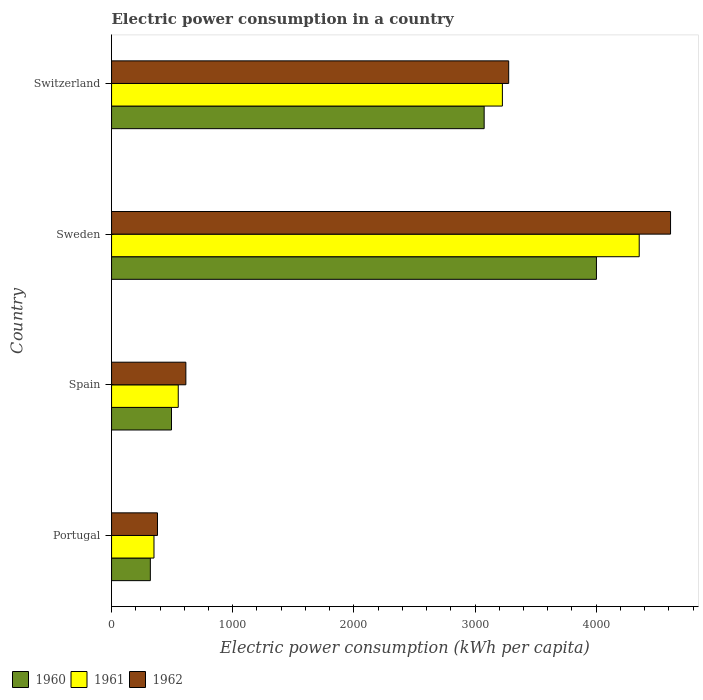How many groups of bars are there?
Provide a short and direct response. 4. How many bars are there on the 4th tick from the top?
Give a very brief answer. 3. How many bars are there on the 3rd tick from the bottom?
Provide a succinct answer. 3. In how many cases, is the number of bars for a given country not equal to the number of legend labels?
Your answer should be very brief. 0. What is the electric power consumption in in 1961 in Spain?
Your response must be concise. 550.44. Across all countries, what is the maximum electric power consumption in in 1961?
Offer a very short reply. 4355.45. Across all countries, what is the minimum electric power consumption in in 1962?
Your answer should be very brief. 379.14. In which country was the electric power consumption in in 1962 minimum?
Provide a succinct answer. Portugal. What is the total electric power consumption in in 1961 in the graph?
Offer a terse response. 8482.08. What is the difference between the electric power consumption in in 1960 in Portugal and that in Sweden?
Make the answer very short. -3682.15. What is the difference between the electric power consumption in in 1960 in Portugal and the electric power consumption in in 1962 in Sweden?
Give a very brief answer. -4293.81. What is the average electric power consumption in in 1961 per country?
Offer a very short reply. 2120.52. What is the difference between the electric power consumption in in 1961 and electric power consumption in in 1960 in Portugal?
Your response must be concise. 30.02. What is the ratio of the electric power consumption in in 1960 in Spain to that in Sweden?
Make the answer very short. 0.12. Is the difference between the electric power consumption in in 1961 in Spain and Switzerland greater than the difference between the electric power consumption in in 1960 in Spain and Switzerland?
Ensure brevity in your answer.  No. What is the difference between the highest and the second highest electric power consumption in in 1960?
Offer a terse response. 926.77. What is the difference between the highest and the lowest electric power consumption in in 1961?
Your answer should be compact. 4005.26. In how many countries, is the electric power consumption in in 1960 greater than the average electric power consumption in in 1960 taken over all countries?
Provide a succinct answer. 2. How many bars are there?
Offer a terse response. 12. Are all the bars in the graph horizontal?
Ensure brevity in your answer.  Yes. What is the difference between two consecutive major ticks on the X-axis?
Give a very brief answer. 1000. Are the values on the major ticks of X-axis written in scientific E-notation?
Your answer should be compact. No. Does the graph contain any zero values?
Give a very brief answer. No. Where does the legend appear in the graph?
Ensure brevity in your answer.  Bottom left. How many legend labels are there?
Your response must be concise. 3. What is the title of the graph?
Your answer should be compact. Electric power consumption in a country. What is the label or title of the X-axis?
Ensure brevity in your answer.  Electric power consumption (kWh per capita). What is the Electric power consumption (kWh per capita) of 1960 in Portugal?
Your answer should be very brief. 320.17. What is the Electric power consumption (kWh per capita) in 1961 in Portugal?
Ensure brevity in your answer.  350.19. What is the Electric power consumption (kWh per capita) in 1962 in Portugal?
Offer a terse response. 379.14. What is the Electric power consumption (kWh per capita) of 1960 in Spain?
Offer a very short reply. 494.8. What is the Electric power consumption (kWh per capita) of 1961 in Spain?
Provide a short and direct response. 550.44. What is the Electric power consumption (kWh per capita) of 1962 in Spain?
Offer a very short reply. 613.25. What is the Electric power consumption (kWh per capita) of 1960 in Sweden?
Give a very brief answer. 4002.32. What is the Electric power consumption (kWh per capita) of 1961 in Sweden?
Provide a short and direct response. 4355.45. What is the Electric power consumption (kWh per capita) of 1962 in Sweden?
Your response must be concise. 4613.98. What is the Electric power consumption (kWh per capita) of 1960 in Switzerland?
Your answer should be compact. 3075.55. What is the Electric power consumption (kWh per capita) of 1961 in Switzerland?
Offer a very short reply. 3225.99. What is the Electric power consumption (kWh per capita) of 1962 in Switzerland?
Give a very brief answer. 3278.01. Across all countries, what is the maximum Electric power consumption (kWh per capita) in 1960?
Provide a succinct answer. 4002.32. Across all countries, what is the maximum Electric power consumption (kWh per capita) of 1961?
Your response must be concise. 4355.45. Across all countries, what is the maximum Electric power consumption (kWh per capita) in 1962?
Give a very brief answer. 4613.98. Across all countries, what is the minimum Electric power consumption (kWh per capita) in 1960?
Provide a succinct answer. 320.17. Across all countries, what is the minimum Electric power consumption (kWh per capita) of 1961?
Give a very brief answer. 350.19. Across all countries, what is the minimum Electric power consumption (kWh per capita) of 1962?
Your answer should be very brief. 379.14. What is the total Electric power consumption (kWh per capita) of 1960 in the graph?
Your answer should be compact. 7892.84. What is the total Electric power consumption (kWh per capita) of 1961 in the graph?
Give a very brief answer. 8482.08. What is the total Electric power consumption (kWh per capita) of 1962 in the graph?
Your response must be concise. 8884.37. What is the difference between the Electric power consumption (kWh per capita) in 1960 in Portugal and that in Spain?
Your answer should be compact. -174.62. What is the difference between the Electric power consumption (kWh per capita) in 1961 in Portugal and that in Spain?
Your answer should be very brief. -200.24. What is the difference between the Electric power consumption (kWh per capita) in 1962 in Portugal and that in Spain?
Make the answer very short. -234.11. What is the difference between the Electric power consumption (kWh per capita) in 1960 in Portugal and that in Sweden?
Your answer should be compact. -3682.15. What is the difference between the Electric power consumption (kWh per capita) in 1961 in Portugal and that in Sweden?
Offer a terse response. -4005.26. What is the difference between the Electric power consumption (kWh per capita) in 1962 in Portugal and that in Sweden?
Your response must be concise. -4234.84. What is the difference between the Electric power consumption (kWh per capita) of 1960 in Portugal and that in Switzerland?
Make the answer very short. -2755.38. What is the difference between the Electric power consumption (kWh per capita) in 1961 in Portugal and that in Switzerland?
Offer a very short reply. -2875.8. What is the difference between the Electric power consumption (kWh per capita) in 1962 in Portugal and that in Switzerland?
Provide a succinct answer. -2898.86. What is the difference between the Electric power consumption (kWh per capita) in 1960 in Spain and that in Sweden?
Make the answer very short. -3507.53. What is the difference between the Electric power consumption (kWh per capita) in 1961 in Spain and that in Sweden?
Your answer should be very brief. -3805.02. What is the difference between the Electric power consumption (kWh per capita) in 1962 in Spain and that in Sweden?
Your response must be concise. -4000.73. What is the difference between the Electric power consumption (kWh per capita) of 1960 in Spain and that in Switzerland?
Make the answer very short. -2580.75. What is the difference between the Electric power consumption (kWh per capita) in 1961 in Spain and that in Switzerland?
Your answer should be compact. -2675.56. What is the difference between the Electric power consumption (kWh per capita) of 1962 in Spain and that in Switzerland?
Ensure brevity in your answer.  -2664.76. What is the difference between the Electric power consumption (kWh per capita) of 1960 in Sweden and that in Switzerland?
Give a very brief answer. 926.77. What is the difference between the Electric power consumption (kWh per capita) in 1961 in Sweden and that in Switzerland?
Your answer should be very brief. 1129.46. What is the difference between the Electric power consumption (kWh per capita) of 1962 in Sweden and that in Switzerland?
Your answer should be very brief. 1335.97. What is the difference between the Electric power consumption (kWh per capita) of 1960 in Portugal and the Electric power consumption (kWh per capita) of 1961 in Spain?
Offer a very short reply. -230.26. What is the difference between the Electric power consumption (kWh per capita) in 1960 in Portugal and the Electric power consumption (kWh per capita) in 1962 in Spain?
Your response must be concise. -293.07. What is the difference between the Electric power consumption (kWh per capita) in 1961 in Portugal and the Electric power consumption (kWh per capita) in 1962 in Spain?
Your answer should be compact. -263.05. What is the difference between the Electric power consumption (kWh per capita) of 1960 in Portugal and the Electric power consumption (kWh per capita) of 1961 in Sweden?
Give a very brief answer. -4035.28. What is the difference between the Electric power consumption (kWh per capita) in 1960 in Portugal and the Electric power consumption (kWh per capita) in 1962 in Sweden?
Keep it short and to the point. -4293.81. What is the difference between the Electric power consumption (kWh per capita) of 1961 in Portugal and the Electric power consumption (kWh per capita) of 1962 in Sweden?
Your answer should be compact. -4263.78. What is the difference between the Electric power consumption (kWh per capita) of 1960 in Portugal and the Electric power consumption (kWh per capita) of 1961 in Switzerland?
Provide a succinct answer. -2905.82. What is the difference between the Electric power consumption (kWh per capita) in 1960 in Portugal and the Electric power consumption (kWh per capita) in 1962 in Switzerland?
Ensure brevity in your answer.  -2957.83. What is the difference between the Electric power consumption (kWh per capita) in 1961 in Portugal and the Electric power consumption (kWh per capita) in 1962 in Switzerland?
Give a very brief answer. -2927.81. What is the difference between the Electric power consumption (kWh per capita) in 1960 in Spain and the Electric power consumption (kWh per capita) in 1961 in Sweden?
Provide a succinct answer. -3860.66. What is the difference between the Electric power consumption (kWh per capita) of 1960 in Spain and the Electric power consumption (kWh per capita) of 1962 in Sweden?
Give a very brief answer. -4119.18. What is the difference between the Electric power consumption (kWh per capita) in 1961 in Spain and the Electric power consumption (kWh per capita) in 1962 in Sweden?
Keep it short and to the point. -4063.54. What is the difference between the Electric power consumption (kWh per capita) in 1960 in Spain and the Electric power consumption (kWh per capita) in 1961 in Switzerland?
Provide a short and direct response. -2731.2. What is the difference between the Electric power consumption (kWh per capita) in 1960 in Spain and the Electric power consumption (kWh per capita) in 1962 in Switzerland?
Your answer should be compact. -2783.21. What is the difference between the Electric power consumption (kWh per capita) of 1961 in Spain and the Electric power consumption (kWh per capita) of 1962 in Switzerland?
Offer a terse response. -2727.57. What is the difference between the Electric power consumption (kWh per capita) of 1960 in Sweden and the Electric power consumption (kWh per capita) of 1961 in Switzerland?
Your answer should be very brief. 776.33. What is the difference between the Electric power consumption (kWh per capita) in 1960 in Sweden and the Electric power consumption (kWh per capita) in 1962 in Switzerland?
Offer a very short reply. 724.32. What is the difference between the Electric power consumption (kWh per capita) of 1961 in Sweden and the Electric power consumption (kWh per capita) of 1962 in Switzerland?
Offer a very short reply. 1077.45. What is the average Electric power consumption (kWh per capita) in 1960 per country?
Make the answer very short. 1973.21. What is the average Electric power consumption (kWh per capita) in 1961 per country?
Make the answer very short. 2120.52. What is the average Electric power consumption (kWh per capita) of 1962 per country?
Your answer should be very brief. 2221.09. What is the difference between the Electric power consumption (kWh per capita) in 1960 and Electric power consumption (kWh per capita) in 1961 in Portugal?
Your response must be concise. -30.02. What is the difference between the Electric power consumption (kWh per capita) of 1960 and Electric power consumption (kWh per capita) of 1962 in Portugal?
Offer a very short reply. -58.97. What is the difference between the Electric power consumption (kWh per capita) in 1961 and Electric power consumption (kWh per capita) in 1962 in Portugal?
Make the answer very short. -28.95. What is the difference between the Electric power consumption (kWh per capita) of 1960 and Electric power consumption (kWh per capita) of 1961 in Spain?
Ensure brevity in your answer.  -55.64. What is the difference between the Electric power consumption (kWh per capita) in 1960 and Electric power consumption (kWh per capita) in 1962 in Spain?
Offer a terse response. -118.45. What is the difference between the Electric power consumption (kWh per capita) in 1961 and Electric power consumption (kWh per capita) in 1962 in Spain?
Your answer should be very brief. -62.81. What is the difference between the Electric power consumption (kWh per capita) of 1960 and Electric power consumption (kWh per capita) of 1961 in Sweden?
Offer a terse response. -353.13. What is the difference between the Electric power consumption (kWh per capita) of 1960 and Electric power consumption (kWh per capita) of 1962 in Sweden?
Provide a short and direct response. -611.66. What is the difference between the Electric power consumption (kWh per capita) of 1961 and Electric power consumption (kWh per capita) of 1962 in Sweden?
Provide a succinct answer. -258.52. What is the difference between the Electric power consumption (kWh per capita) in 1960 and Electric power consumption (kWh per capita) in 1961 in Switzerland?
Your answer should be compact. -150.44. What is the difference between the Electric power consumption (kWh per capita) of 1960 and Electric power consumption (kWh per capita) of 1962 in Switzerland?
Ensure brevity in your answer.  -202.46. What is the difference between the Electric power consumption (kWh per capita) of 1961 and Electric power consumption (kWh per capita) of 1962 in Switzerland?
Keep it short and to the point. -52.01. What is the ratio of the Electric power consumption (kWh per capita) of 1960 in Portugal to that in Spain?
Offer a terse response. 0.65. What is the ratio of the Electric power consumption (kWh per capita) in 1961 in Portugal to that in Spain?
Provide a short and direct response. 0.64. What is the ratio of the Electric power consumption (kWh per capita) in 1962 in Portugal to that in Spain?
Your answer should be compact. 0.62. What is the ratio of the Electric power consumption (kWh per capita) of 1960 in Portugal to that in Sweden?
Your answer should be very brief. 0.08. What is the ratio of the Electric power consumption (kWh per capita) of 1961 in Portugal to that in Sweden?
Offer a terse response. 0.08. What is the ratio of the Electric power consumption (kWh per capita) of 1962 in Portugal to that in Sweden?
Provide a short and direct response. 0.08. What is the ratio of the Electric power consumption (kWh per capita) of 1960 in Portugal to that in Switzerland?
Offer a terse response. 0.1. What is the ratio of the Electric power consumption (kWh per capita) of 1961 in Portugal to that in Switzerland?
Make the answer very short. 0.11. What is the ratio of the Electric power consumption (kWh per capita) in 1962 in Portugal to that in Switzerland?
Provide a short and direct response. 0.12. What is the ratio of the Electric power consumption (kWh per capita) of 1960 in Spain to that in Sweden?
Your response must be concise. 0.12. What is the ratio of the Electric power consumption (kWh per capita) of 1961 in Spain to that in Sweden?
Keep it short and to the point. 0.13. What is the ratio of the Electric power consumption (kWh per capita) in 1962 in Spain to that in Sweden?
Give a very brief answer. 0.13. What is the ratio of the Electric power consumption (kWh per capita) in 1960 in Spain to that in Switzerland?
Your answer should be very brief. 0.16. What is the ratio of the Electric power consumption (kWh per capita) in 1961 in Spain to that in Switzerland?
Give a very brief answer. 0.17. What is the ratio of the Electric power consumption (kWh per capita) in 1962 in Spain to that in Switzerland?
Offer a terse response. 0.19. What is the ratio of the Electric power consumption (kWh per capita) in 1960 in Sweden to that in Switzerland?
Your response must be concise. 1.3. What is the ratio of the Electric power consumption (kWh per capita) of 1961 in Sweden to that in Switzerland?
Provide a succinct answer. 1.35. What is the ratio of the Electric power consumption (kWh per capita) in 1962 in Sweden to that in Switzerland?
Ensure brevity in your answer.  1.41. What is the difference between the highest and the second highest Electric power consumption (kWh per capita) of 1960?
Provide a short and direct response. 926.77. What is the difference between the highest and the second highest Electric power consumption (kWh per capita) of 1961?
Your answer should be very brief. 1129.46. What is the difference between the highest and the second highest Electric power consumption (kWh per capita) in 1962?
Offer a very short reply. 1335.97. What is the difference between the highest and the lowest Electric power consumption (kWh per capita) in 1960?
Offer a terse response. 3682.15. What is the difference between the highest and the lowest Electric power consumption (kWh per capita) in 1961?
Provide a succinct answer. 4005.26. What is the difference between the highest and the lowest Electric power consumption (kWh per capita) of 1962?
Make the answer very short. 4234.84. 